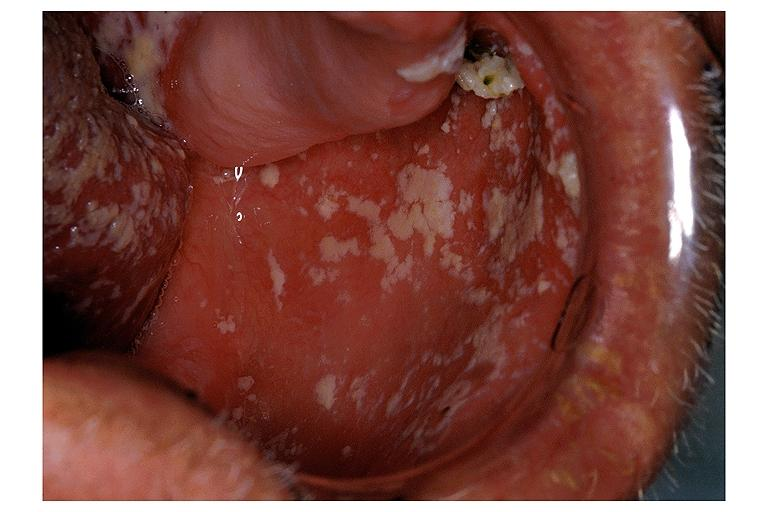where is this?
Answer the question using a single word or phrase. Oral 